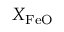<formula> <loc_0><loc_0><loc_500><loc_500>X _ { F e O }</formula> 